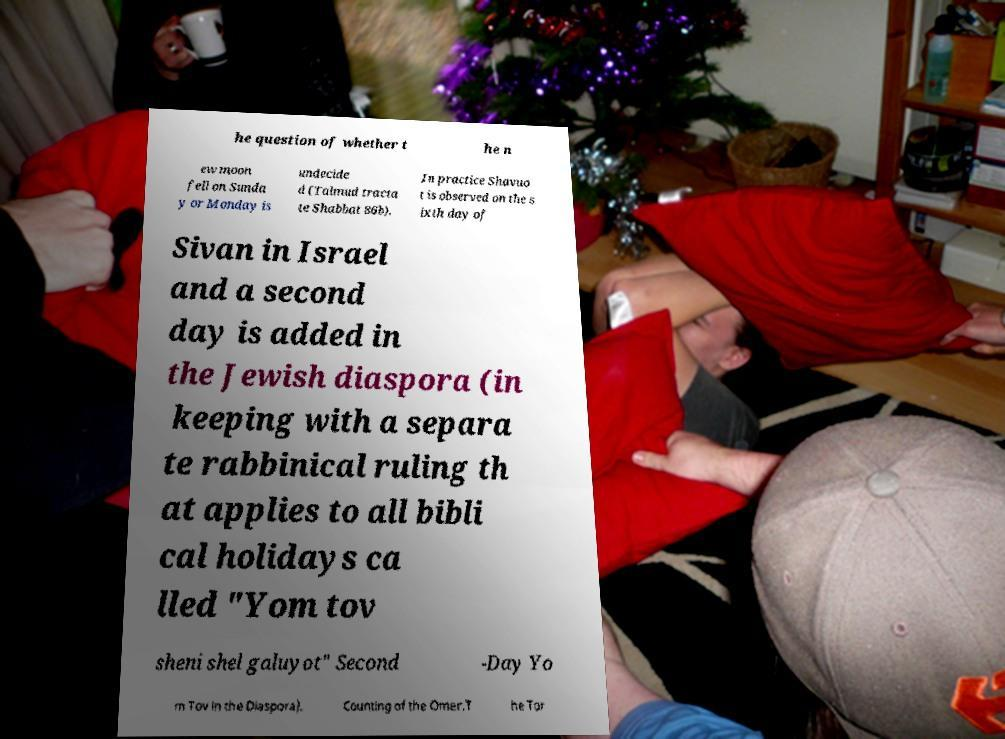I need the written content from this picture converted into text. Can you do that? he question of whether t he n ew moon fell on Sunda y or Monday is undecide d (Talmud tracta te Shabbat 86b). In practice Shavuo t is observed on the s ixth day of Sivan in Israel and a second day is added in the Jewish diaspora (in keeping with a separa te rabbinical ruling th at applies to all bibli cal holidays ca lled "Yom tov sheni shel galuyot" Second -Day Yo m Tov in the Diaspora). Counting of the Omer.T he Tor 